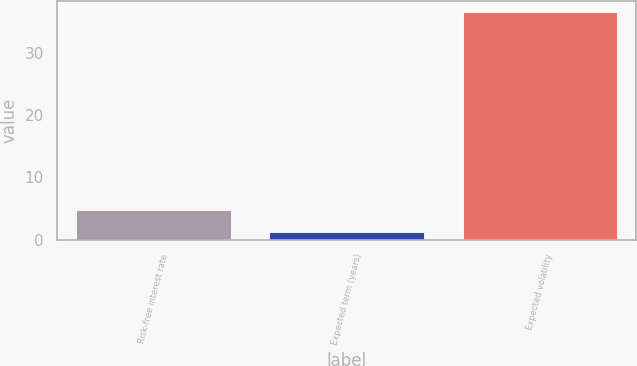Convert chart to OTSL. <chart><loc_0><loc_0><loc_500><loc_500><bar_chart><fcel>Risk-free interest rate<fcel>Expected term (years)<fcel>Expected volatility<nl><fcel>4.73<fcel>1.2<fcel>36.52<nl></chart> 